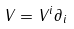Convert formula to latex. <formula><loc_0><loc_0><loc_500><loc_500>V = V ^ { i } \partial _ { i }</formula> 